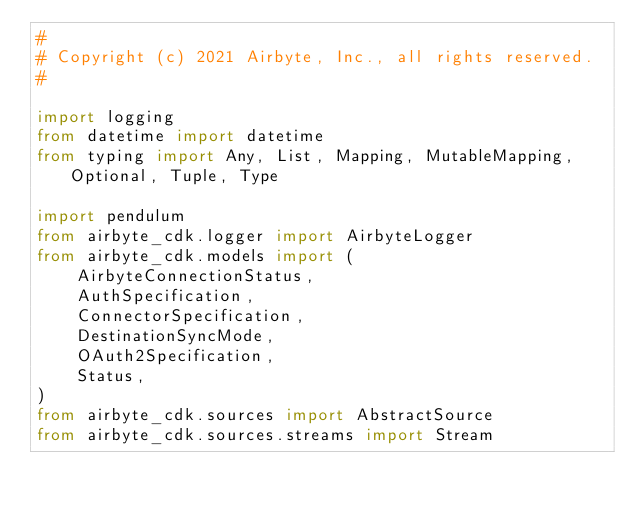<code> <loc_0><loc_0><loc_500><loc_500><_Python_>#
# Copyright (c) 2021 Airbyte, Inc., all rights reserved.
#

import logging
from datetime import datetime
from typing import Any, List, Mapping, MutableMapping, Optional, Tuple, Type

import pendulum
from airbyte_cdk.logger import AirbyteLogger
from airbyte_cdk.models import (
    AirbyteConnectionStatus,
    AuthSpecification,
    ConnectorSpecification,
    DestinationSyncMode,
    OAuth2Specification,
    Status,
)
from airbyte_cdk.sources import AbstractSource
from airbyte_cdk.sources.streams import Stream</code> 